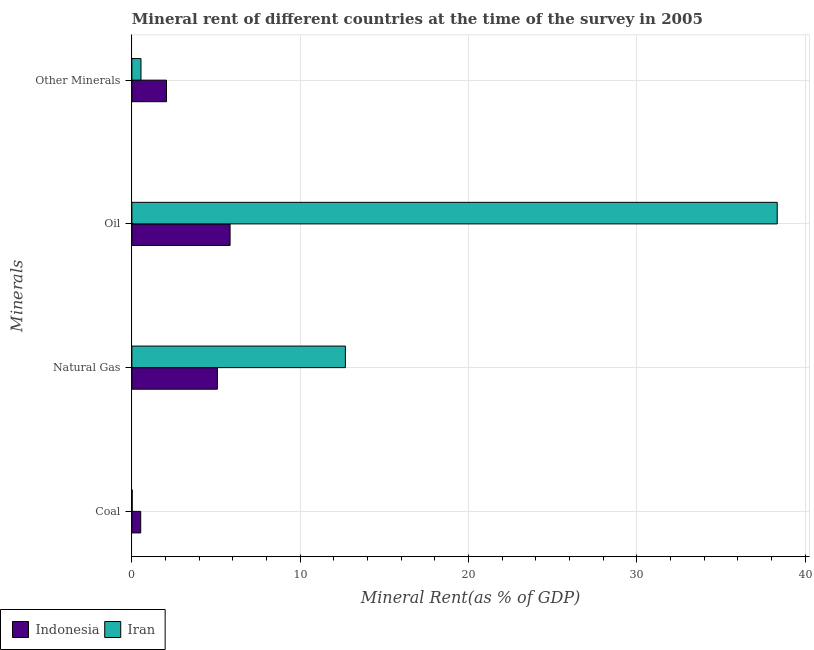How many groups of bars are there?
Give a very brief answer. 4. Are the number of bars per tick equal to the number of legend labels?
Provide a short and direct response. Yes. How many bars are there on the 2nd tick from the top?
Offer a terse response. 2. What is the label of the 1st group of bars from the top?
Your answer should be compact. Other Minerals. What is the  rent of other minerals in Iran?
Offer a very short reply. 0.54. Across all countries, what is the maximum  rent of other minerals?
Ensure brevity in your answer.  2.06. Across all countries, what is the minimum coal rent?
Keep it short and to the point. 0.02. In which country was the oil rent maximum?
Provide a short and direct response. Iran. In which country was the coal rent minimum?
Provide a succinct answer. Iran. What is the total  rent of other minerals in the graph?
Keep it short and to the point. 2.6. What is the difference between the coal rent in Iran and that in Indonesia?
Your response must be concise. -0.51. What is the difference between the oil rent in Iran and the coal rent in Indonesia?
Provide a succinct answer. 37.82. What is the average oil rent per country?
Give a very brief answer. 22.09. What is the difference between the natural gas rent and coal rent in Indonesia?
Give a very brief answer. 4.56. In how many countries, is the  rent of other minerals greater than 34 %?
Keep it short and to the point. 0. What is the ratio of the oil rent in Iran to that in Indonesia?
Keep it short and to the point. 6.57. What is the difference between the highest and the second highest coal rent?
Your answer should be compact. 0.51. What is the difference between the highest and the lowest  rent of other minerals?
Your answer should be compact. 1.52. Is the sum of the natural gas rent in Indonesia and Iran greater than the maximum oil rent across all countries?
Make the answer very short. No. Is it the case that in every country, the sum of the oil rent and natural gas rent is greater than the sum of coal rent and  rent of other minerals?
Your answer should be compact. Yes. What does the 1st bar from the top in Natural Gas represents?
Your answer should be very brief. Iran. How many bars are there?
Give a very brief answer. 8. Are all the bars in the graph horizontal?
Ensure brevity in your answer.  Yes. How many countries are there in the graph?
Make the answer very short. 2. How many legend labels are there?
Provide a succinct answer. 2. How are the legend labels stacked?
Offer a terse response. Horizontal. What is the title of the graph?
Give a very brief answer. Mineral rent of different countries at the time of the survey in 2005. What is the label or title of the X-axis?
Your answer should be very brief. Mineral Rent(as % of GDP). What is the label or title of the Y-axis?
Offer a very short reply. Minerals. What is the Mineral Rent(as % of GDP) of Indonesia in Coal?
Give a very brief answer. 0.53. What is the Mineral Rent(as % of GDP) in Iran in Coal?
Give a very brief answer. 0.02. What is the Mineral Rent(as % of GDP) of Indonesia in Natural Gas?
Your answer should be very brief. 5.08. What is the Mineral Rent(as % of GDP) in Iran in Natural Gas?
Your answer should be compact. 12.69. What is the Mineral Rent(as % of GDP) in Indonesia in Oil?
Your response must be concise. 5.84. What is the Mineral Rent(as % of GDP) of Iran in Oil?
Provide a succinct answer. 38.35. What is the Mineral Rent(as % of GDP) of Indonesia in Other Minerals?
Your response must be concise. 2.06. What is the Mineral Rent(as % of GDP) of Iran in Other Minerals?
Provide a succinct answer. 0.54. Across all Minerals, what is the maximum Mineral Rent(as % of GDP) of Indonesia?
Make the answer very short. 5.84. Across all Minerals, what is the maximum Mineral Rent(as % of GDP) in Iran?
Provide a succinct answer. 38.35. Across all Minerals, what is the minimum Mineral Rent(as % of GDP) in Indonesia?
Give a very brief answer. 0.53. Across all Minerals, what is the minimum Mineral Rent(as % of GDP) in Iran?
Provide a succinct answer. 0.02. What is the total Mineral Rent(as % of GDP) in Indonesia in the graph?
Make the answer very short. 13.5. What is the total Mineral Rent(as % of GDP) in Iran in the graph?
Your answer should be very brief. 51.6. What is the difference between the Mineral Rent(as % of GDP) in Indonesia in Coal and that in Natural Gas?
Keep it short and to the point. -4.56. What is the difference between the Mineral Rent(as % of GDP) of Iran in Coal and that in Natural Gas?
Keep it short and to the point. -12.67. What is the difference between the Mineral Rent(as % of GDP) of Indonesia in Coal and that in Oil?
Your response must be concise. -5.31. What is the difference between the Mineral Rent(as % of GDP) of Iran in Coal and that in Oil?
Your answer should be very brief. -38.33. What is the difference between the Mineral Rent(as % of GDP) in Indonesia in Coal and that in Other Minerals?
Your answer should be very brief. -1.53. What is the difference between the Mineral Rent(as % of GDP) in Iran in Coal and that in Other Minerals?
Offer a terse response. -0.52. What is the difference between the Mineral Rent(as % of GDP) of Indonesia in Natural Gas and that in Oil?
Your answer should be compact. -0.75. What is the difference between the Mineral Rent(as % of GDP) of Iran in Natural Gas and that in Oil?
Offer a terse response. -25.66. What is the difference between the Mineral Rent(as % of GDP) of Indonesia in Natural Gas and that in Other Minerals?
Offer a very short reply. 3.02. What is the difference between the Mineral Rent(as % of GDP) of Iran in Natural Gas and that in Other Minerals?
Provide a succinct answer. 12.15. What is the difference between the Mineral Rent(as % of GDP) in Indonesia in Oil and that in Other Minerals?
Provide a succinct answer. 3.78. What is the difference between the Mineral Rent(as % of GDP) in Iran in Oil and that in Other Minerals?
Your answer should be compact. 37.81. What is the difference between the Mineral Rent(as % of GDP) in Indonesia in Coal and the Mineral Rent(as % of GDP) in Iran in Natural Gas?
Give a very brief answer. -12.16. What is the difference between the Mineral Rent(as % of GDP) of Indonesia in Coal and the Mineral Rent(as % of GDP) of Iran in Oil?
Your answer should be very brief. -37.82. What is the difference between the Mineral Rent(as % of GDP) in Indonesia in Coal and the Mineral Rent(as % of GDP) in Iran in Other Minerals?
Your answer should be compact. -0.01. What is the difference between the Mineral Rent(as % of GDP) of Indonesia in Natural Gas and the Mineral Rent(as % of GDP) of Iran in Oil?
Your answer should be very brief. -33.27. What is the difference between the Mineral Rent(as % of GDP) of Indonesia in Natural Gas and the Mineral Rent(as % of GDP) of Iran in Other Minerals?
Your answer should be compact. 4.54. What is the difference between the Mineral Rent(as % of GDP) in Indonesia in Oil and the Mineral Rent(as % of GDP) in Iran in Other Minerals?
Your answer should be compact. 5.3. What is the average Mineral Rent(as % of GDP) in Indonesia per Minerals?
Your answer should be compact. 3.37. What is the average Mineral Rent(as % of GDP) in Iran per Minerals?
Your answer should be compact. 12.9. What is the difference between the Mineral Rent(as % of GDP) of Indonesia and Mineral Rent(as % of GDP) of Iran in Coal?
Your answer should be very brief. 0.51. What is the difference between the Mineral Rent(as % of GDP) in Indonesia and Mineral Rent(as % of GDP) in Iran in Natural Gas?
Offer a very short reply. -7.61. What is the difference between the Mineral Rent(as % of GDP) in Indonesia and Mineral Rent(as % of GDP) in Iran in Oil?
Your response must be concise. -32.51. What is the difference between the Mineral Rent(as % of GDP) of Indonesia and Mineral Rent(as % of GDP) of Iran in Other Minerals?
Provide a succinct answer. 1.52. What is the ratio of the Mineral Rent(as % of GDP) in Indonesia in Coal to that in Natural Gas?
Give a very brief answer. 0.1. What is the ratio of the Mineral Rent(as % of GDP) of Iran in Coal to that in Natural Gas?
Provide a succinct answer. 0. What is the ratio of the Mineral Rent(as % of GDP) of Indonesia in Coal to that in Oil?
Your answer should be compact. 0.09. What is the ratio of the Mineral Rent(as % of GDP) in Iran in Coal to that in Oil?
Offer a terse response. 0. What is the ratio of the Mineral Rent(as % of GDP) in Indonesia in Coal to that in Other Minerals?
Keep it short and to the point. 0.26. What is the ratio of the Mineral Rent(as % of GDP) of Iran in Coal to that in Other Minerals?
Your answer should be very brief. 0.03. What is the ratio of the Mineral Rent(as % of GDP) in Indonesia in Natural Gas to that in Oil?
Keep it short and to the point. 0.87. What is the ratio of the Mineral Rent(as % of GDP) in Iran in Natural Gas to that in Oil?
Your response must be concise. 0.33. What is the ratio of the Mineral Rent(as % of GDP) of Indonesia in Natural Gas to that in Other Minerals?
Provide a succinct answer. 2.47. What is the ratio of the Mineral Rent(as % of GDP) in Iran in Natural Gas to that in Other Minerals?
Your answer should be compact. 23.49. What is the ratio of the Mineral Rent(as % of GDP) of Indonesia in Oil to that in Other Minerals?
Offer a very short reply. 2.84. What is the ratio of the Mineral Rent(as % of GDP) of Iran in Oil to that in Other Minerals?
Your answer should be compact. 71. What is the difference between the highest and the second highest Mineral Rent(as % of GDP) of Indonesia?
Your answer should be very brief. 0.75. What is the difference between the highest and the second highest Mineral Rent(as % of GDP) of Iran?
Provide a succinct answer. 25.66. What is the difference between the highest and the lowest Mineral Rent(as % of GDP) of Indonesia?
Provide a short and direct response. 5.31. What is the difference between the highest and the lowest Mineral Rent(as % of GDP) in Iran?
Ensure brevity in your answer.  38.33. 